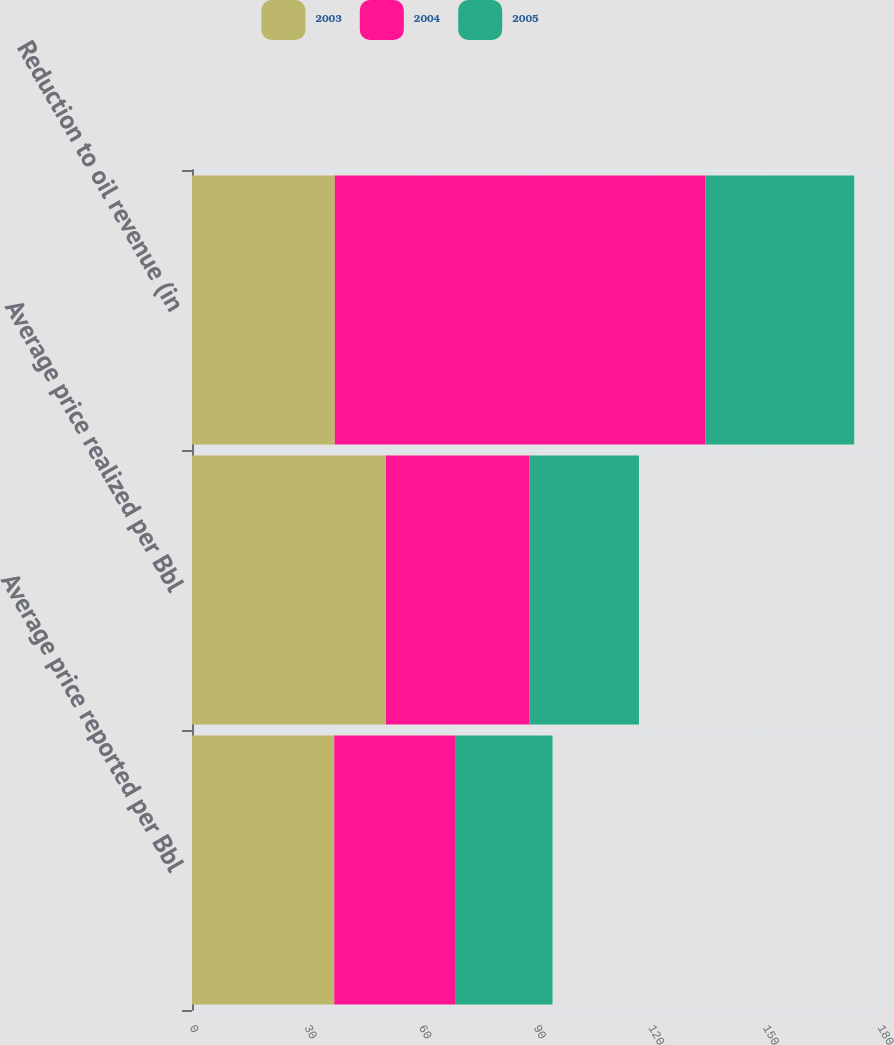<chart> <loc_0><loc_0><loc_500><loc_500><stacked_bar_chart><ecel><fcel>Average price reported per Bbl<fcel>Average price realized per Bbl<fcel>Reduction to oil revenue (in<nl><fcel>2003<fcel>37.22<fcel>50.74<fcel>37.355<nl><fcel>2004<fcel>31.6<fcel>37.49<fcel>97<nl><fcel>2005<fcel>25.5<fcel>28.71<fcel>38.9<nl></chart> 